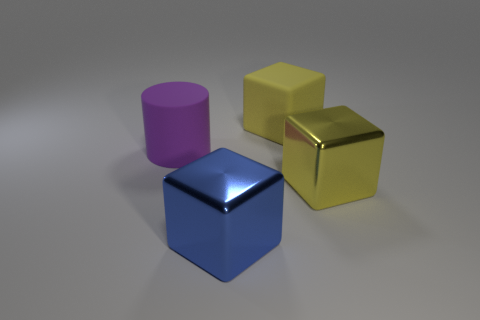Do the large metal block that is right of the large blue shiny block and the large matte block have the same color?
Give a very brief answer. Yes. Are there more large cubes on the right side of the blue block than tiny red cubes?
Offer a terse response. Yes. Is there anything else that is the same color as the big matte cube?
Offer a very short reply. Yes. What shape is the object left of the block in front of the large yellow metal object?
Your answer should be very brief. Cylinder. Is the number of cylinders greater than the number of big cubes?
Provide a succinct answer. No. What number of things are both behind the yellow metallic cube and left of the big matte cube?
Give a very brief answer. 1. What number of metal things are on the right side of the yellow object behind the large purple matte object?
Make the answer very short. 1. How many things are big metal things that are left of the rubber block or large metallic objects in front of the big yellow metal block?
Provide a short and direct response. 1. What material is the other yellow object that is the same shape as the big yellow metal object?
Offer a very short reply. Rubber. How many things are either large objects that are behind the big purple cylinder or purple matte cylinders?
Your response must be concise. 2. 